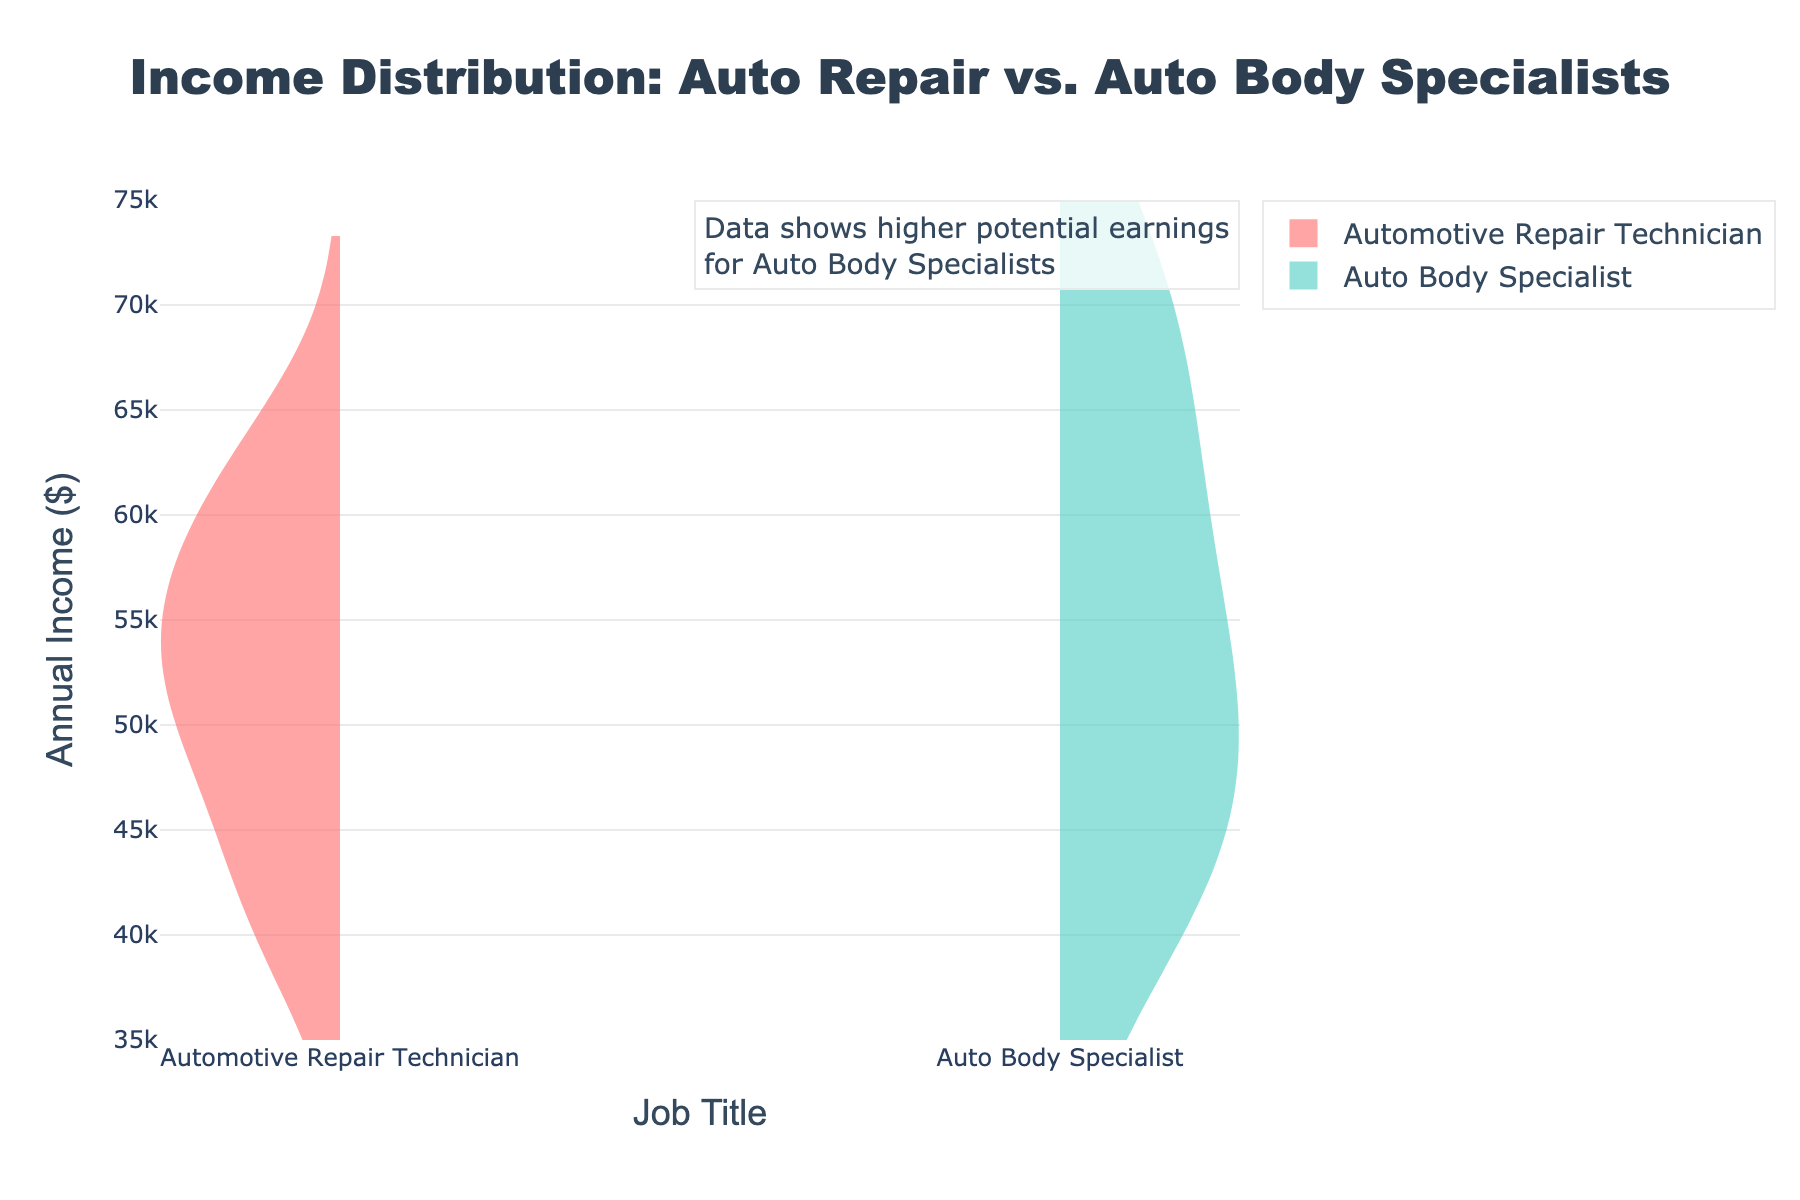What is the title of the figure? The title of the figure is often located at the top center of the chart. In this case, it says "Income Distribution: Auto Repair vs. Auto Body Specialists".
Answer: Income Distribution: Auto Repair vs. Auto Body Specialists What does the y-axis represent? The y-axis usually has a title that describes the data it measures. Here, the y-axis is labeled as "Annual Income ($)", indicating it shows the annual income in dollars.
Answer: Annual Income ($) Which job title shows a wider distribution of income? By observing the spread of the violin plots, the job title with a wider distribution will have a broader and more spread out shape. The distribution for "Auto Body Specialist" looks wider and more diverse compared to "Automotive Repair Technician".
Answer: Auto Body Specialist What is the minimum annual income recorded for Auto Body Specialists? The minimum value is identified by the lowest point of the “Auto Body Specialist” violin plot. The plot shows its minimum value close to $41,000.
Answer: 41000 What is the median income for Automotive Repair Technicians? The median is the middle point of the data. In a violin plot, it is usually indicated by a white dot or thicker line in the center. The median for Automotive Repair Technicians appears to be around $50,000.
Answer: 50000 Which job title has the highest potential earnings according to the plot? The highest annual income is read from the top points of the violin plots. The highest value for Auto Body Specialists is about $72,000, indicated at the topmost part of the plot.
Answer: Auto Body Specialists What is the interquartile range (IQR) for Auto Body Specialists? The IQR spans from the 25th to 75th percentiles of the data. By examining the thicker parts of the violin, the IQR for Auto Body Specialists can be estimated from approximately $46,000 to $65,000 ($65,000 - $46,000 = $19,000).
Answer: 19000 Compare the average annual incomes between the two job titles? The average income can be visually estimated by looking at the central mass of the violin plots. Automotive Repair Technicians average around $52,000, while Auto Body Specialists average closer to $60,000. Comparing these, Auto Body Specialists have a higher average annual income.
Answer: Auto Body Specialists Which group has a more symmetric income distribution? Symmetry in the violin plot is noted by the comparison of both sides of the plot. "Automotive Repair Technician" has a more symmetrical violin plot compared to the somewhat right-skewed distribution of "Auto Body Specialists".
Answer: Automotive Repair Technicians Where does most of the income data concentrate for Automotive Repair Technicians? Concentration areas are where the violin plot is thickest. For Automotive Repair Technicians, this thick section appears around the $50,000 to $55,000 range, indicating most incomes fall within this range.
Answer: $50,000 to $55,000 